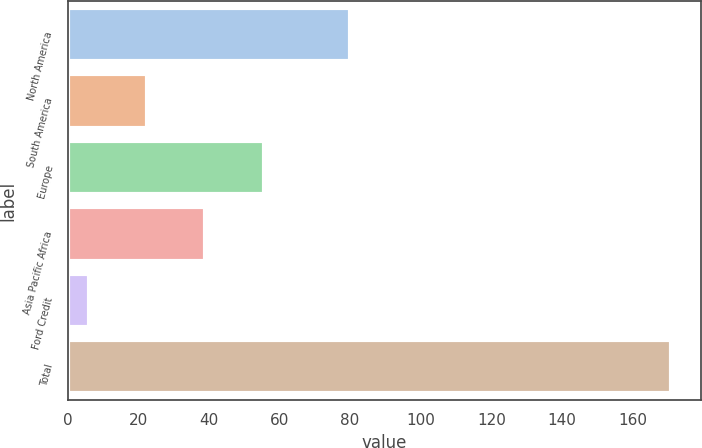Convert chart to OTSL. <chart><loc_0><loc_0><loc_500><loc_500><bar_chart><fcel>North America<fcel>South America<fcel>Europe<fcel>Asia Pacific Africa<fcel>Ford Credit<fcel>Total<nl><fcel>80<fcel>22.5<fcel>55.5<fcel>39<fcel>6<fcel>171<nl></chart> 